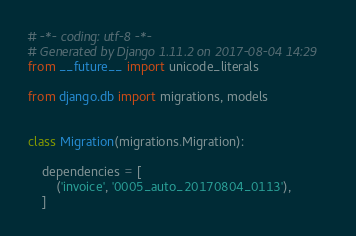<code> <loc_0><loc_0><loc_500><loc_500><_Python_># -*- coding: utf-8 -*-
# Generated by Django 1.11.2 on 2017-08-04 14:29
from __future__ import unicode_literals

from django.db import migrations, models


class Migration(migrations.Migration):

    dependencies = [
        ('invoice', '0005_auto_20170804_0113'),
    ]
</code> 